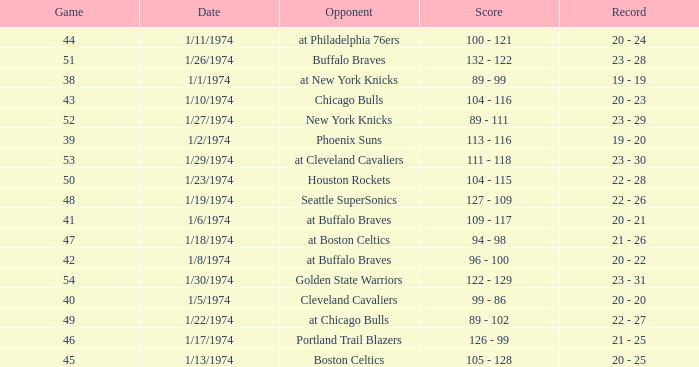What was the score on 1/10/1974? 104 - 116. 